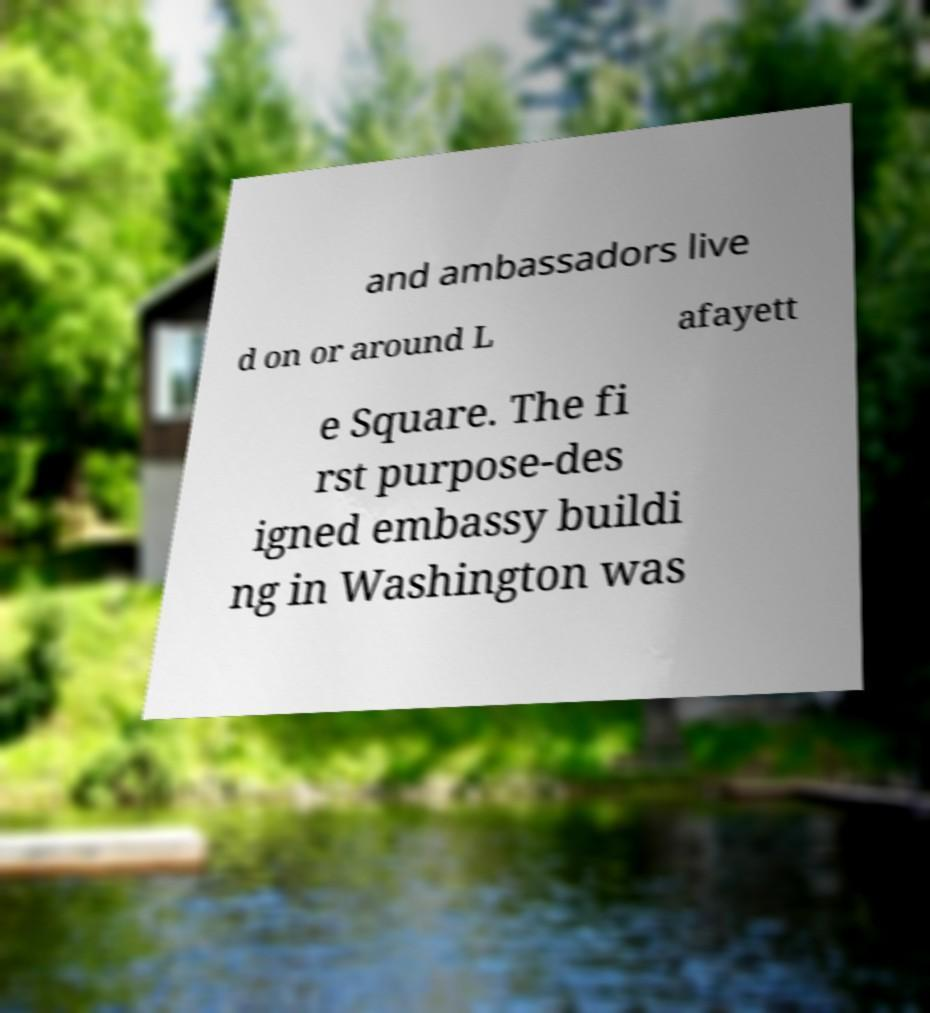Can you read and provide the text displayed in the image?This photo seems to have some interesting text. Can you extract and type it out for me? and ambassadors live d on or around L afayett e Square. The fi rst purpose-des igned embassy buildi ng in Washington was 